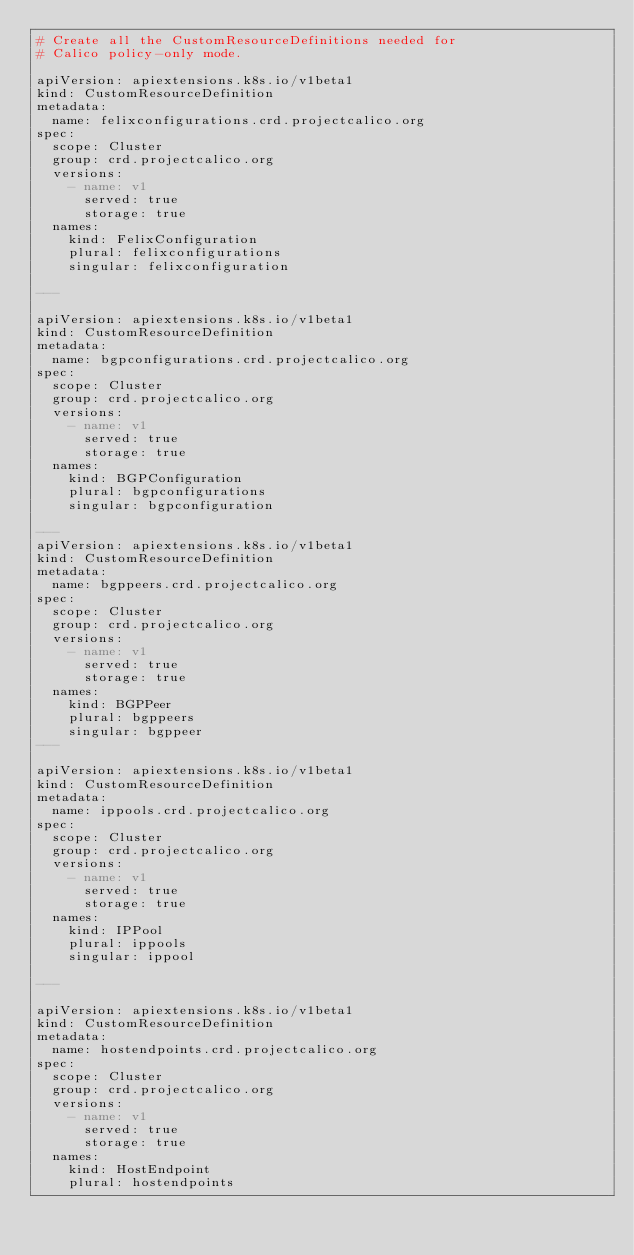<code> <loc_0><loc_0><loc_500><loc_500><_YAML_># Create all the CustomResourceDefinitions needed for
# Calico policy-only mode.

apiVersion: apiextensions.k8s.io/v1beta1
kind: CustomResourceDefinition
metadata:
  name: felixconfigurations.crd.projectcalico.org
spec:
  scope: Cluster
  group: crd.projectcalico.org
  versions:
    - name: v1
      served: true
      storage: true
  names:
    kind: FelixConfiguration
    plural: felixconfigurations
    singular: felixconfiguration

---

apiVersion: apiextensions.k8s.io/v1beta1
kind: CustomResourceDefinition
metadata:
  name: bgpconfigurations.crd.projectcalico.org
spec:
  scope: Cluster
  group: crd.projectcalico.org
  versions:
    - name: v1
      served: true
      storage: true
  names:
    kind: BGPConfiguration
    plural: bgpconfigurations
    singular: bgpconfiguration

---
apiVersion: apiextensions.k8s.io/v1beta1
kind: CustomResourceDefinition
metadata:
  name: bgppeers.crd.projectcalico.org
spec:
  scope: Cluster
  group: crd.projectcalico.org
  versions:
    - name: v1
      served: true
      storage: true
  names:
    kind: BGPPeer
    plural: bgppeers
    singular: bgppeer
---

apiVersion: apiextensions.k8s.io/v1beta1
kind: CustomResourceDefinition
metadata:
  name: ippools.crd.projectcalico.org
spec:
  scope: Cluster
  group: crd.projectcalico.org
  versions:
    - name: v1
      served: true
      storage: true
  names:
    kind: IPPool
    plural: ippools
    singular: ippool

---

apiVersion: apiextensions.k8s.io/v1beta1
kind: CustomResourceDefinition
metadata:
  name: hostendpoints.crd.projectcalico.org
spec:
  scope: Cluster
  group: crd.projectcalico.org
  versions:
    - name: v1
      served: true
      storage: true
  names:
    kind: HostEndpoint
    plural: hostendpoints</code> 